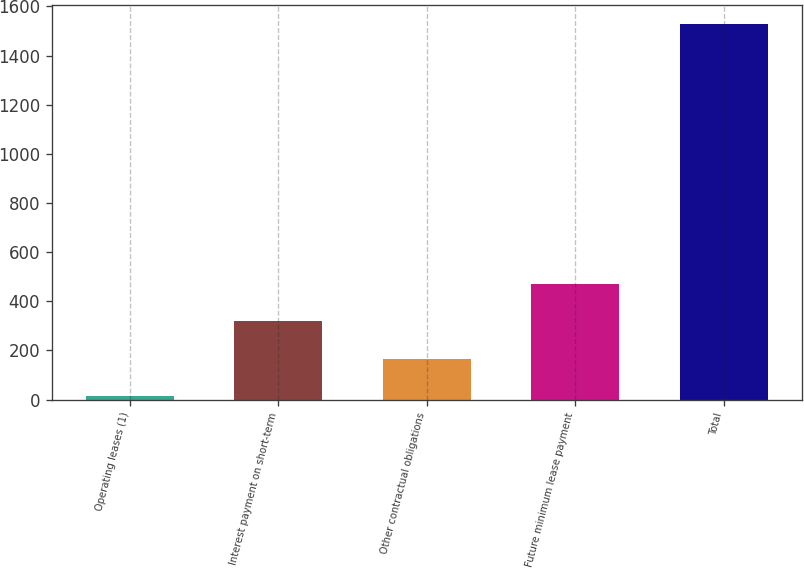Convert chart to OTSL. <chart><loc_0><loc_0><loc_500><loc_500><bar_chart><fcel>Operating leases (1)<fcel>Interest payment on short-term<fcel>Other contractual obligations<fcel>Future minimum lease payment<fcel>Total<nl><fcel>15.7<fcel>318.22<fcel>166.96<fcel>469.48<fcel>1528.3<nl></chart> 